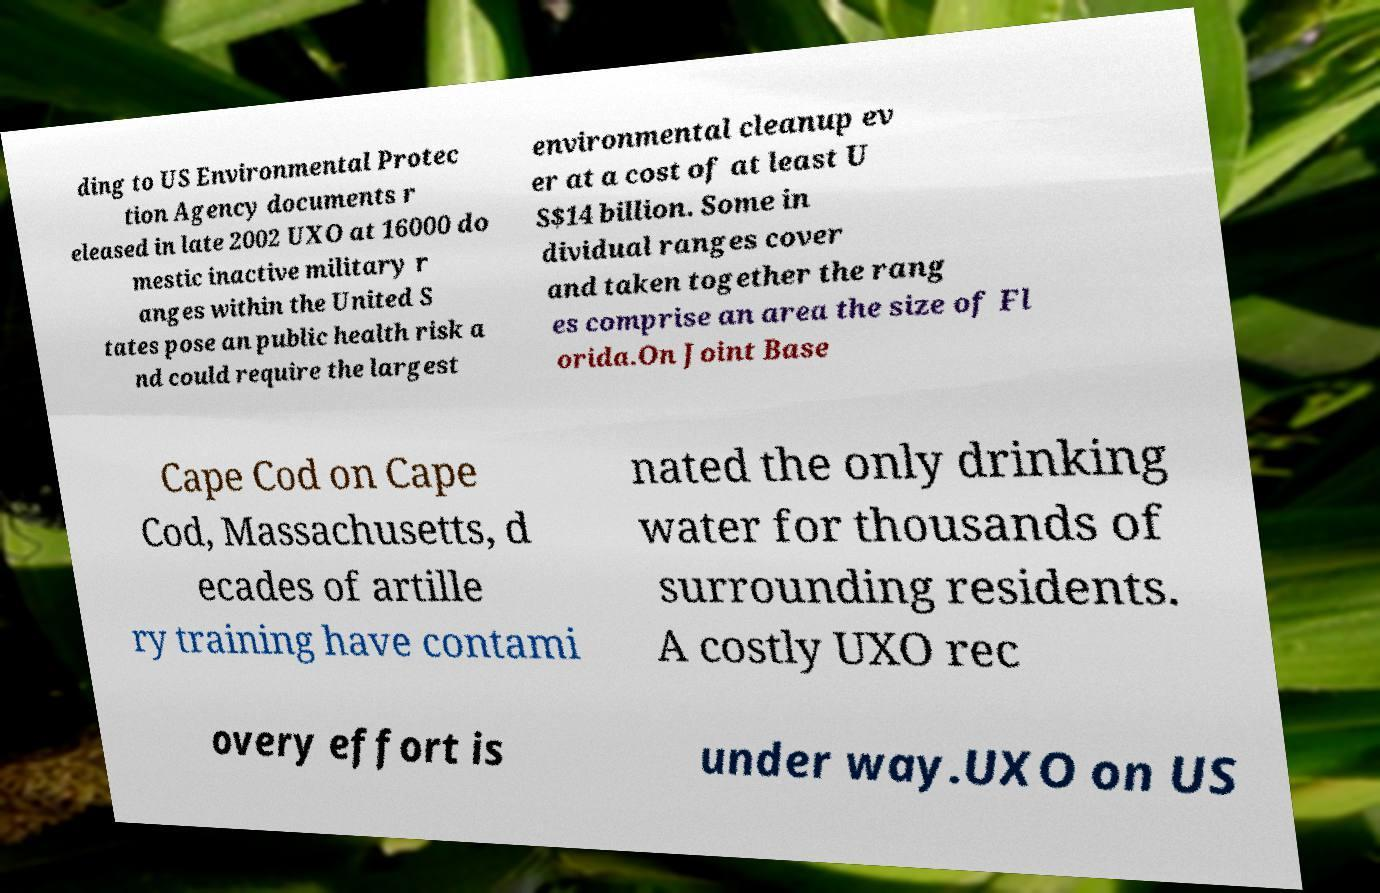For documentation purposes, I need the text within this image transcribed. Could you provide that? ding to US Environmental Protec tion Agency documents r eleased in late 2002 UXO at 16000 do mestic inactive military r anges within the United S tates pose an public health risk a nd could require the largest environmental cleanup ev er at a cost of at least U S$14 billion. Some in dividual ranges cover and taken together the rang es comprise an area the size of Fl orida.On Joint Base Cape Cod on Cape Cod, Massachusetts, d ecades of artille ry training have contami nated the only drinking water for thousands of surrounding residents. A costly UXO rec overy effort is under way.UXO on US 